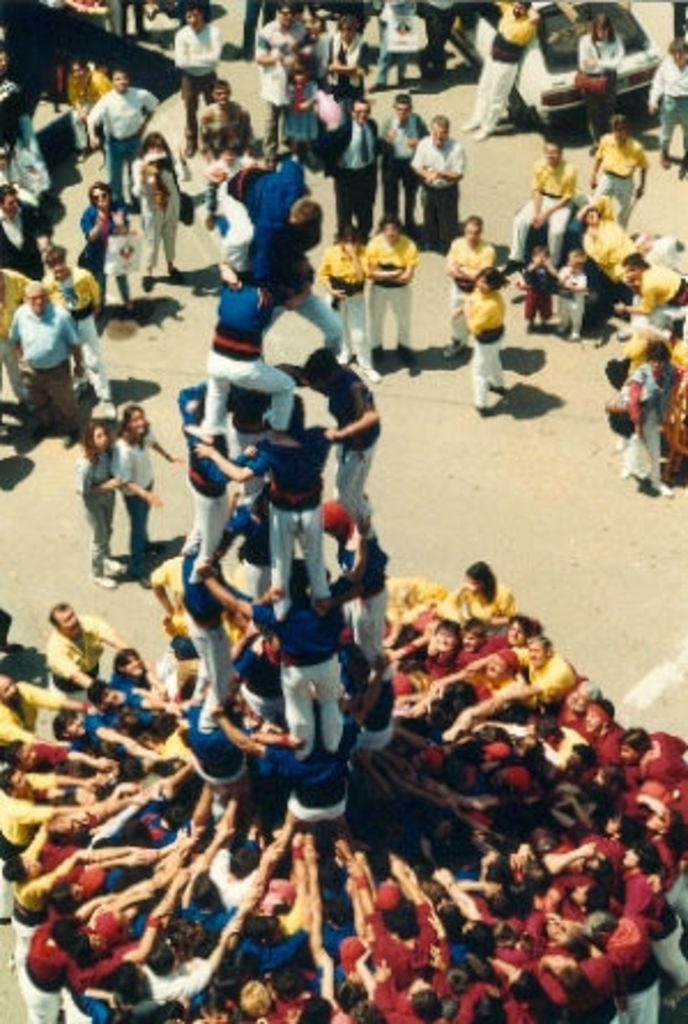How many people are in the image? There is a group of people in the image. What can be observed about the clothing of the people in the image? The people are wearing different color dresses. What else can be seen in the image besides the people? There is a vehicle visible in the image. Where are the people located in the image? The people are on the road. What type of cast can be seen on the mother's arm in the image? There is no mother or cast present in the image. How does the vehicle pull the people along the road in the image? The vehicle does not pull the people in the image; they are on the road but not being pulled by the vehicle. 